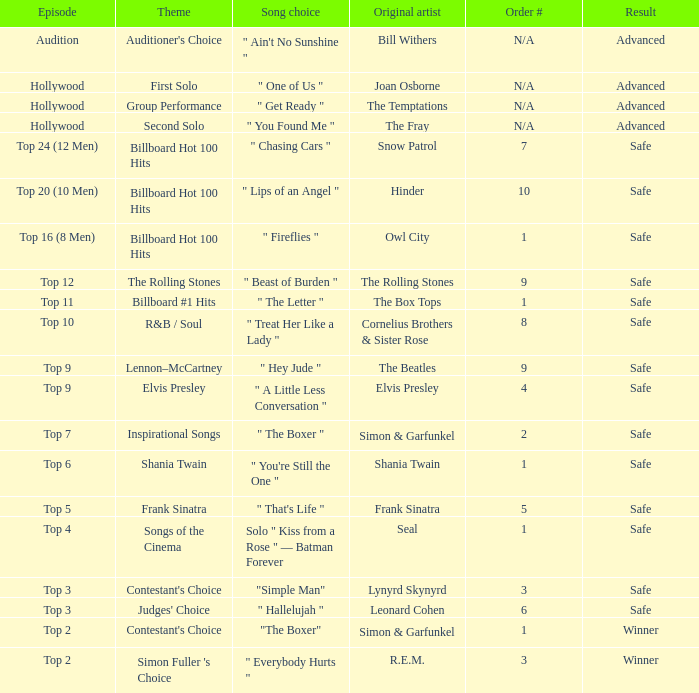In episode top 16 (8 men), what are the main concepts? Billboard Hot 100 Hits. 